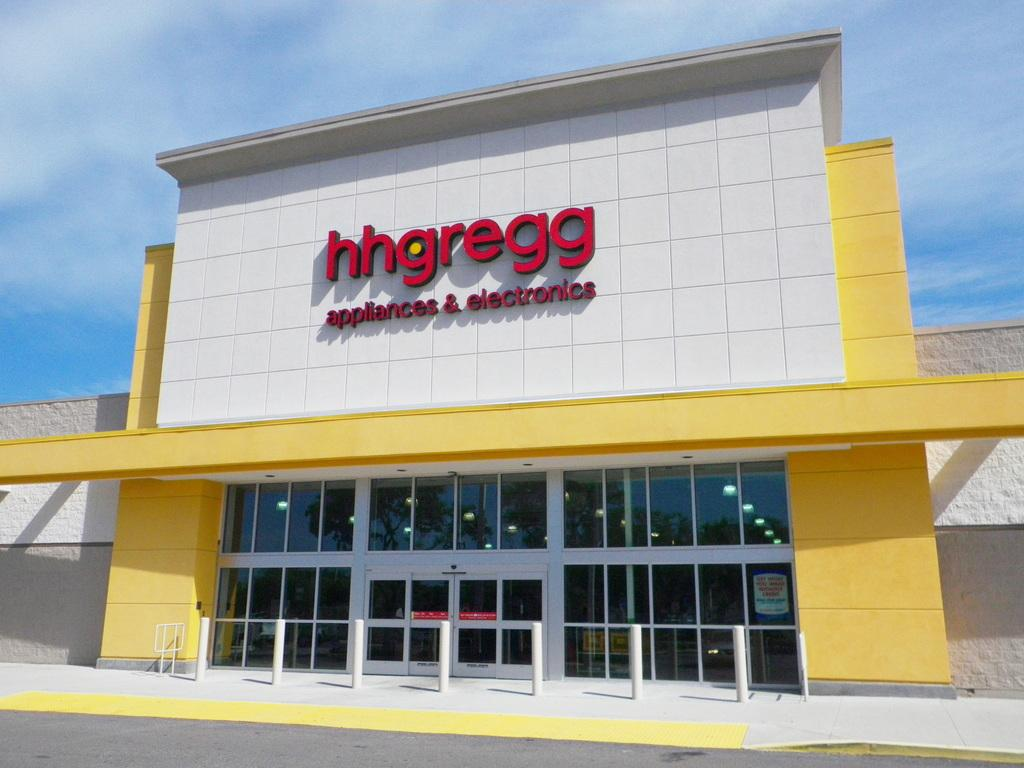What type of structure is present in the image? There is a building in the image. What can be seen in the background of the image? The sky is visible in the background of the image. How many yams are being carried by the hen in the image? There are no yams or hens present in the image; it features a building and the sky. 